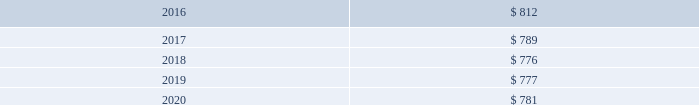Nbcuniversal media , llc indefinite-lived intangible assets indefinite-lived intangible assets consist of trade names and fcc licenses .
We assess the recoverability of our indefinite-lived intangible assets annually , or more frequently whenever events or substantive changes in circumstances indicate that the assets might be impaired .
We evaluate the unit of account used to test for impairment of our indefinite-lived intangible assets periodically or whenever events or substantive changes in circumstances occur to ensure impairment testing is performed at an appropriate level .
The assessment of recoverability may first consider qualitative factors to determine whether it is more likely than not that the fair value of an indefinite-lived intangible asset is less than its carrying amount .
A quantitative assessment is per- formed if the qualitative assessment results in a more-likely-than-not determination or if a qualitative assessment is not performed .
When performing a quantitative assessment , we estimate the fair value of our indefinite-lived intangible assets primarily based on a discounted cash flow analysis that involves significant judgment .
When analyzing the fair values indicated under the discounted cash flow models , we also consider multiples of operating income before depreciation and amortization generated by the underlying assets , cur- rent market transactions , and profitability information .
If the fair value of our indefinite-lived intangible assets were less than the carrying amount , we would recognize an impairment charge for the difference between the estimated fair value and the carrying value of the assets .
Unless presented separately , the impairment charge is included as a component of amortization expense .
We did not recognize any material impairment charges in any of the periods presented .
Finite-lived intangible assets estimated amortization expense of finite-lived intangible assets ( in millions ) .
Finite-lived intangible assets are subject to amortization and consist primarily of customer relationships acquired in business combinations , intellectual property rights and software .
Our finite-lived intangible assets are amortized primarily on a straight-line basis over their estimated useful life or the term of the associated agreement .
We capitalize direct development costs associated with internal-use software , including external direct costs of material and services and payroll costs for employees devoting time to these software projects .
We also capitalize costs associated with the purchase of software licenses .
We include these costs in intangible assets and generally amortize them on a straight-line basis over a period not to exceed five years .
We expense maintenance and training costs , as well as costs incurred during the preliminary stage of a project , as they are incurred .
We capitalize initial operating system software costs and amortize them over the life of the associated hardware .
We evaluate the recoverability of our finite-lived intangible assets whenever events or substantive changes in circumstances indicate that the carrying amount may not be recoverable .
The evaluation is based on the cash flows generated by the underlying asset groups , including estimated future operating results , trends or other determinants of fair value .
If the total of the expected future undiscounted cash flows were less than the carry- ing amount of the asset group , we would recognize an impairment charge to the extent the carrying amount of the asset group exceeded its estimated fair value .
Unless presented separately , the impairment charge is included as a component of amortization expense .
Comcast 2015 annual report on form 10-k 162 .
What was the ratio of the finite lived intangible assets estimated amortization in 2016 compared to 2017? 
Computations: (812 / 789)
Answer: 1.02915. 